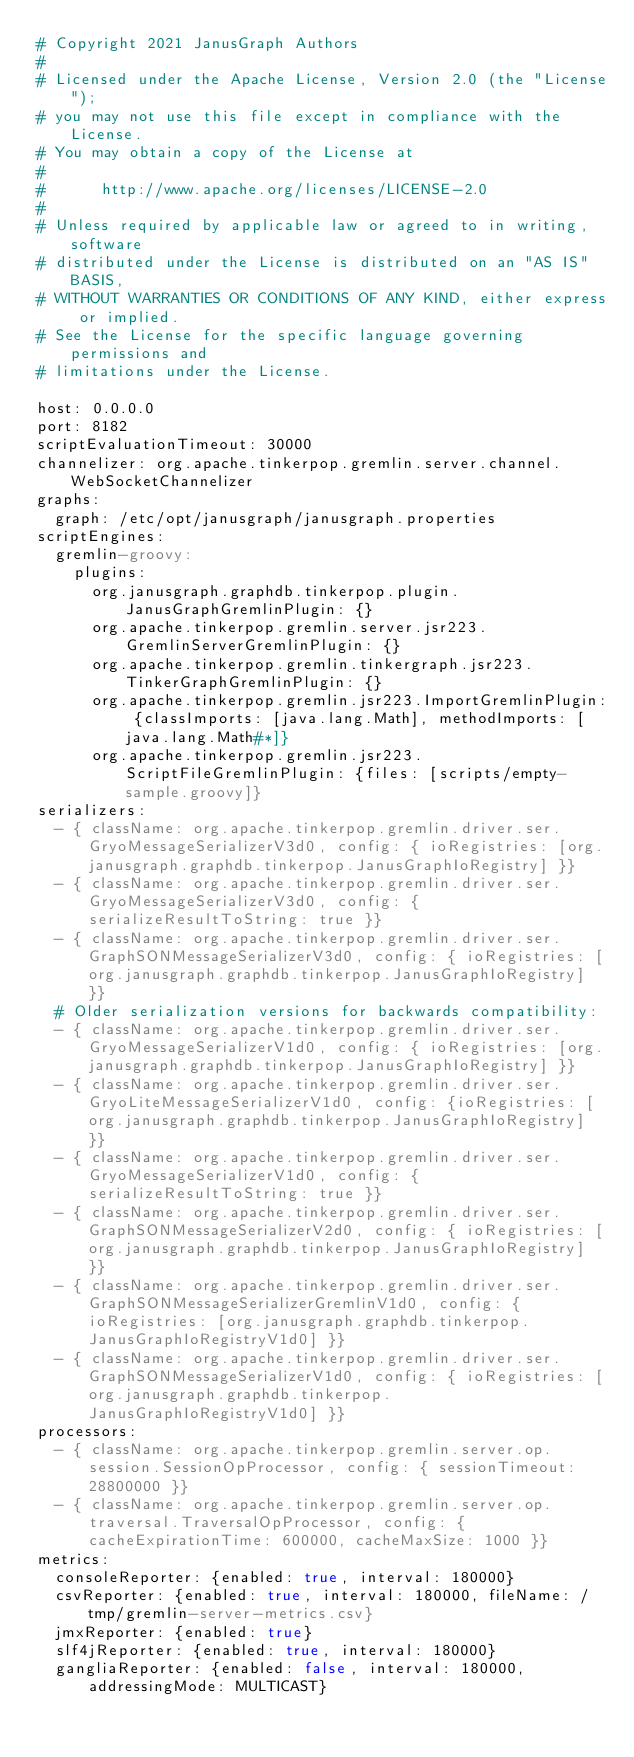Convert code to text. <code><loc_0><loc_0><loc_500><loc_500><_YAML_># Copyright 2021 JanusGraph Authors
#
# Licensed under the Apache License, Version 2.0 (the "License");
# you may not use this file except in compliance with the License.
# You may obtain a copy of the License at
#
#      http://www.apache.org/licenses/LICENSE-2.0
#
# Unless required by applicable law or agreed to in writing, software
# distributed under the License is distributed on an "AS IS" BASIS,
# WITHOUT WARRANTIES OR CONDITIONS OF ANY KIND, either express or implied.
# See the License for the specific language governing permissions and
# limitations under the License.

host: 0.0.0.0
port: 8182
scriptEvaluationTimeout: 30000
channelizer: org.apache.tinkerpop.gremlin.server.channel.WebSocketChannelizer
graphs:
  graph: /etc/opt/janusgraph/janusgraph.properties
scriptEngines:
  gremlin-groovy:
    plugins:
      org.janusgraph.graphdb.tinkerpop.plugin.JanusGraphGremlinPlugin: {}
      org.apache.tinkerpop.gremlin.server.jsr223.GremlinServerGremlinPlugin: {}
      org.apache.tinkerpop.gremlin.tinkergraph.jsr223.TinkerGraphGremlinPlugin: {}
      org.apache.tinkerpop.gremlin.jsr223.ImportGremlinPlugin: {classImports: [java.lang.Math], methodImports: [java.lang.Math#*]}
      org.apache.tinkerpop.gremlin.jsr223.ScriptFileGremlinPlugin: {files: [scripts/empty-sample.groovy]}
serializers:
  - { className: org.apache.tinkerpop.gremlin.driver.ser.GryoMessageSerializerV3d0, config: { ioRegistries: [org.janusgraph.graphdb.tinkerpop.JanusGraphIoRegistry] }}
  - { className: org.apache.tinkerpop.gremlin.driver.ser.GryoMessageSerializerV3d0, config: { serializeResultToString: true }}
  - { className: org.apache.tinkerpop.gremlin.driver.ser.GraphSONMessageSerializerV3d0, config: { ioRegistries: [org.janusgraph.graphdb.tinkerpop.JanusGraphIoRegistry] }}
  # Older serialization versions for backwards compatibility:
  - { className: org.apache.tinkerpop.gremlin.driver.ser.GryoMessageSerializerV1d0, config: { ioRegistries: [org.janusgraph.graphdb.tinkerpop.JanusGraphIoRegistry] }}
  - { className: org.apache.tinkerpop.gremlin.driver.ser.GryoLiteMessageSerializerV1d0, config: {ioRegistries: [org.janusgraph.graphdb.tinkerpop.JanusGraphIoRegistry] }}
  - { className: org.apache.tinkerpop.gremlin.driver.ser.GryoMessageSerializerV1d0, config: { serializeResultToString: true }}
  - { className: org.apache.tinkerpop.gremlin.driver.ser.GraphSONMessageSerializerV2d0, config: { ioRegistries: [org.janusgraph.graphdb.tinkerpop.JanusGraphIoRegistry] }}
  - { className: org.apache.tinkerpop.gremlin.driver.ser.GraphSONMessageSerializerGremlinV1d0, config: { ioRegistries: [org.janusgraph.graphdb.tinkerpop.JanusGraphIoRegistryV1d0] }}
  - { className: org.apache.tinkerpop.gremlin.driver.ser.GraphSONMessageSerializerV1d0, config: { ioRegistries: [org.janusgraph.graphdb.tinkerpop.JanusGraphIoRegistryV1d0] }}
processors:
  - { className: org.apache.tinkerpop.gremlin.server.op.session.SessionOpProcessor, config: { sessionTimeout: 28800000 }}
  - { className: org.apache.tinkerpop.gremlin.server.op.traversal.TraversalOpProcessor, config: { cacheExpirationTime: 600000, cacheMaxSize: 1000 }}
metrics:
  consoleReporter: {enabled: true, interval: 180000}
  csvReporter: {enabled: true, interval: 180000, fileName: /tmp/gremlin-server-metrics.csv}
  jmxReporter: {enabled: true}
  slf4jReporter: {enabled: true, interval: 180000}
  gangliaReporter: {enabled: false, interval: 180000, addressingMode: MULTICAST}</code> 